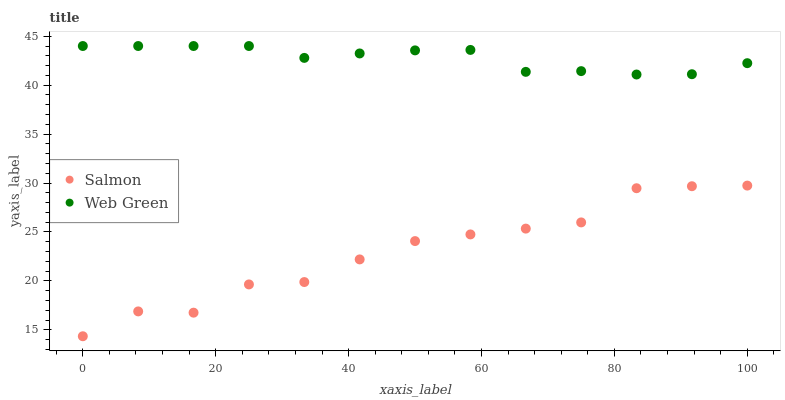Does Salmon have the minimum area under the curve?
Answer yes or no. Yes. Does Web Green have the maximum area under the curve?
Answer yes or no. Yes. Does Web Green have the minimum area under the curve?
Answer yes or no. No. Is Web Green the smoothest?
Answer yes or no. Yes. Is Salmon the roughest?
Answer yes or no. Yes. Is Web Green the roughest?
Answer yes or no. No. Does Salmon have the lowest value?
Answer yes or no. Yes. Does Web Green have the lowest value?
Answer yes or no. No. Does Web Green have the highest value?
Answer yes or no. Yes. Is Salmon less than Web Green?
Answer yes or no. Yes. Is Web Green greater than Salmon?
Answer yes or no. Yes. Does Salmon intersect Web Green?
Answer yes or no. No. 